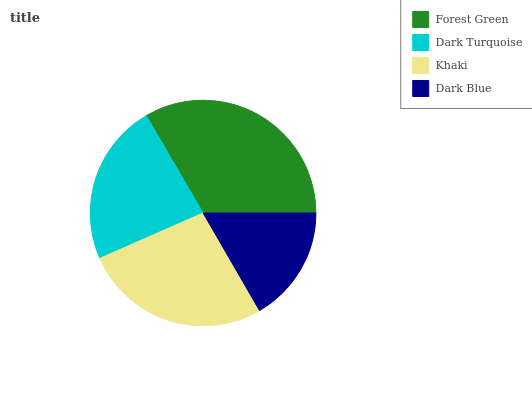Is Dark Blue the minimum?
Answer yes or no. Yes. Is Forest Green the maximum?
Answer yes or no. Yes. Is Dark Turquoise the minimum?
Answer yes or no. No. Is Dark Turquoise the maximum?
Answer yes or no. No. Is Forest Green greater than Dark Turquoise?
Answer yes or no. Yes. Is Dark Turquoise less than Forest Green?
Answer yes or no. Yes. Is Dark Turquoise greater than Forest Green?
Answer yes or no. No. Is Forest Green less than Dark Turquoise?
Answer yes or no. No. Is Khaki the high median?
Answer yes or no. Yes. Is Dark Turquoise the low median?
Answer yes or no. Yes. Is Forest Green the high median?
Answer yes or no. No. Is Dark Blue the low median?
Answer yes or no. No. 